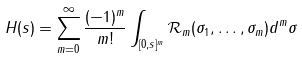Convert formula to latex. <formula><loc_0><loc_0><loc_500><loc_500>H ( s ) = \sum _ { m = 0 } ^ { \infty } \frac { ( - 1 ) ^ { m } } { m ! } \int _ { [ 0 , s ] ^ { m } } \mathcal { R } _ { m } ( \sigma _ { 1 } , \dots , \sigma _ { m } ) d ^ { m } \sigma</formula> 